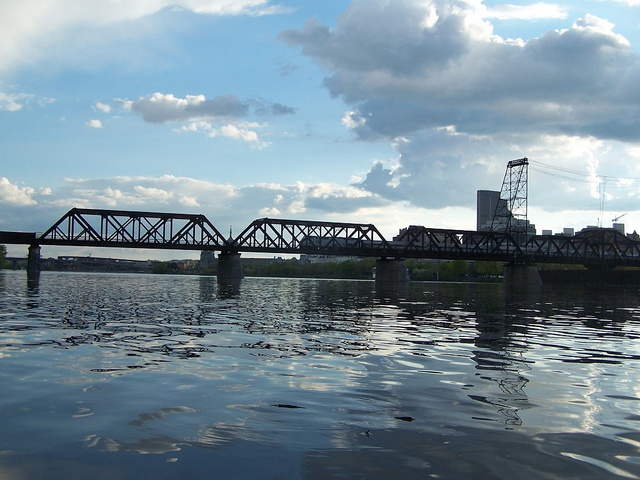Describe the objects in this image and their specific colors. I can see a train in lightgray, black, darkblue, and blue tones in this image. 